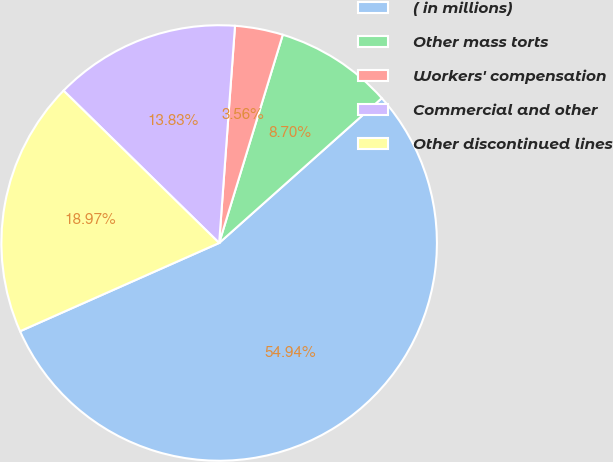Convert chart to OTSL. <chart><loc_0><loc_0><loc_500><loc_500><pie_chart><fcel>( in millions)<fcel>Other mass torts<fcel>Workers' compensation<fcel>Commercial and other<fcel>Other discontinued lines<nl><fcel>54.94%<fcel>8.7%<fcel>3.56%<fcel>13.83%<fcel>18.97%<nl></chart> 